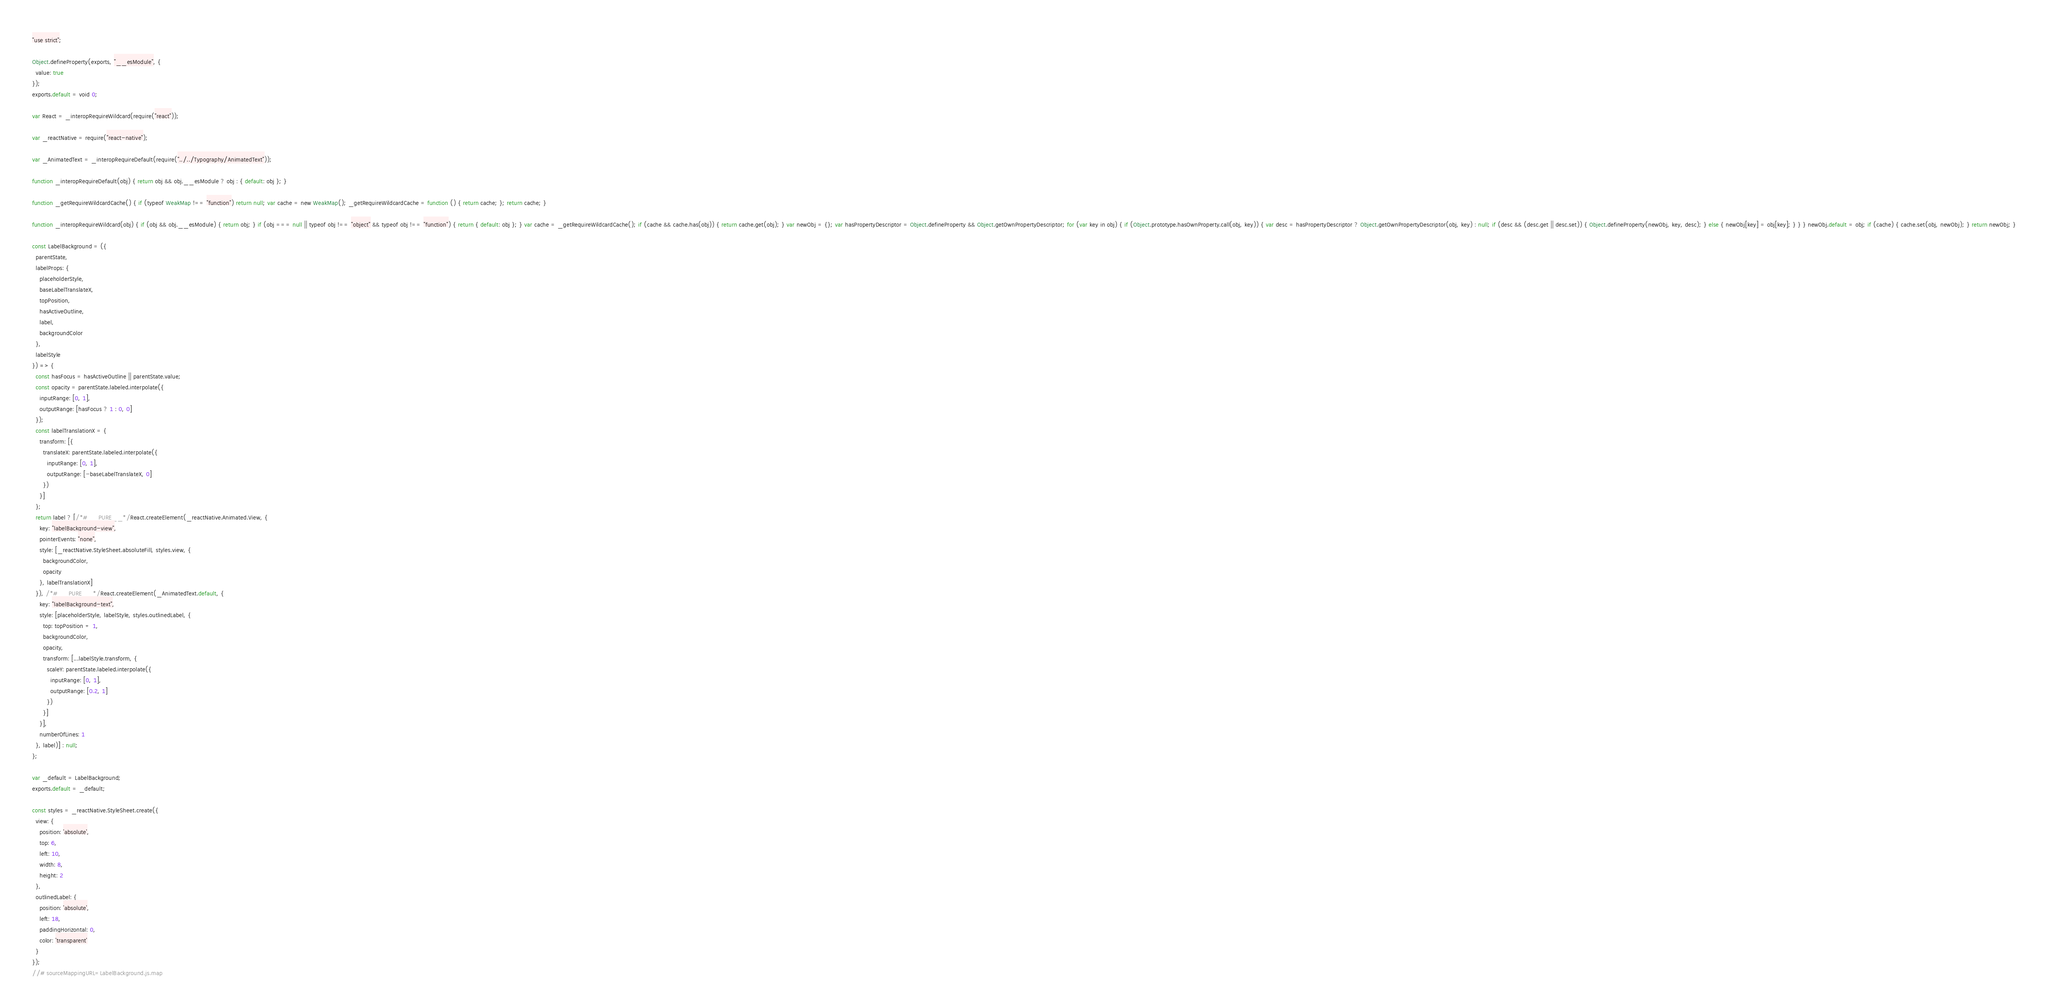Convert code to text. <code><loc_0><loc_0><loc_500><loc_500><_JavaScript_>"use strict";

Object.defineProperty(exports, "__esModule", {
  value: true
});
exports.default = void 0;

var React = _interopRequireWildcard(require("react"));

var _reactNative = require("react-native");

var _AnimatedText = _interopRequireDefault(require("../../Typography/AnimatedText"));

function _interopRequireDefault(obj) { return obj && obj.__esModule ? obj : { default: obj }; }

function _getRequireWildcardCache() { if (typeof WeakMap !== "function") return null; var cache = new WeakMap(); _getRequireWildcardCache = function () { return cache; }; return cache; }

function _interopRequireWildcard(obj) { if (obj && obj.__esModule) { return obj; } if (obj === null || typeof obj !== "object" && typeof obj !== "function") { return { default: obj }; } var cache = _getRequireWildcardCache(); if (cache && cache.has(obj)) { return cache.get(obj); } var newObj = {}; var hasPropertyDescriptor = Object.defineProperty && Object.getOwnPropertyDescriptor; for (var key in obj) { if (Object.prototype.hasOwnProperty.call(obj, key)) { var desc = hasPropertyDescriptor ? Object.getOwnPropertyDescriptor(obj, key) : null; if (desc && (desc.get || desc.set)) { Object.defineProperty(newObj, key, desc); } else { newObj[key] = obj[key]; } } } newObj.default = obj; if (cache) { cache.set(obj, newObj); } return newObj; }

const LabelBackground = ({
  parentState,
  labelProps: {
    placeholderStyle,
    baseLabelTranslateX,
    topPosition,
    hasActiveOutline,
    label,
    backgroundColor
  },
  labelStyle
}) => {
  const hasFocus = hasActiveOutline || parentState.value;
  const opacity = parentState.labeled.interpolate({
    inputRange: [0, 1],
    outputRange: [hasFocus ? 1 : 0, 0]
  });
  const labelTranslationX = {
    transform: [{
      translateX: parentState.labeled.interpolate({
        inputRange: [0, 1],
        outputRange: [-baseLabelTranslateX, 0]
      })
    }]
  };
  return label ? [/*#__PURE__*/React.createElement(_reactNative.Animated.View, {
    key: "labelBackground-view",
    pointerEvents: "none",
    style: [_reactNative.StyleSheet.absoluteFill, styles.view, {
      backgroundColor,
      opacity
    }, labelTranslationX]
  }), /*#__PURE__*/React.createElement(_AnimatedText.default, {
    key: "labelBackground-text",
    style: [placeholderStyle, labelStyle, styles.outlinedLabel, {
      top: topPosition + 1,
      backgroundColor,
      opacity,
      transform: [...labelStyle.transform, {
        scaleY: parentState.labeled.interpolate({
          inputRange: [0, 1],
          outputRange: [0.2, 1]
        })
      }]
    }],
    numberOfLines: 1
  }, label)] : null;
};

var _default = LabelBackground;
exports.default = _default;

const styles = _reactNative.StyleSheet.create({
  view: {
    position: 'absolute',
    top: 6,
    left: 10,
    width: 8,
    height: 2
  },
  outlinedLabel: {
    position: 'absolute',
    left: 18,
    paddingHorizontal: 0,
    color: 'transparent'
  }
});
//# sourceMappingURL=LabelBackground.js.map</code> 